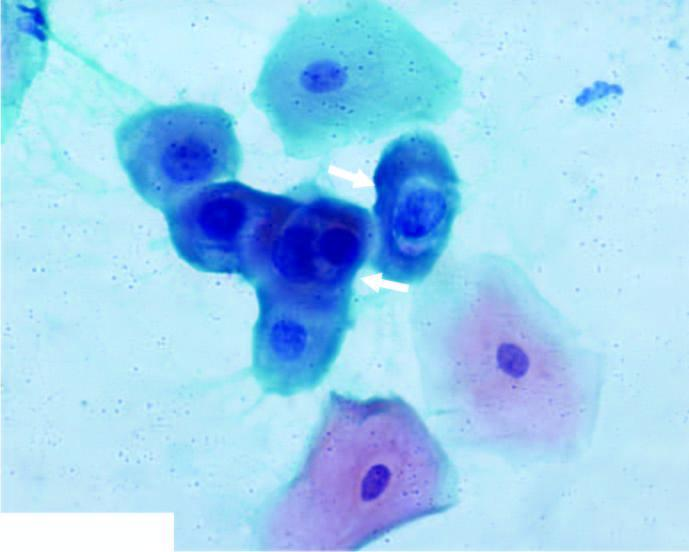what does the smear show?
Answer the question using a single word or phrase. Koilocytes having abundant vacuolated cytoplasm and nuclear enlargement 